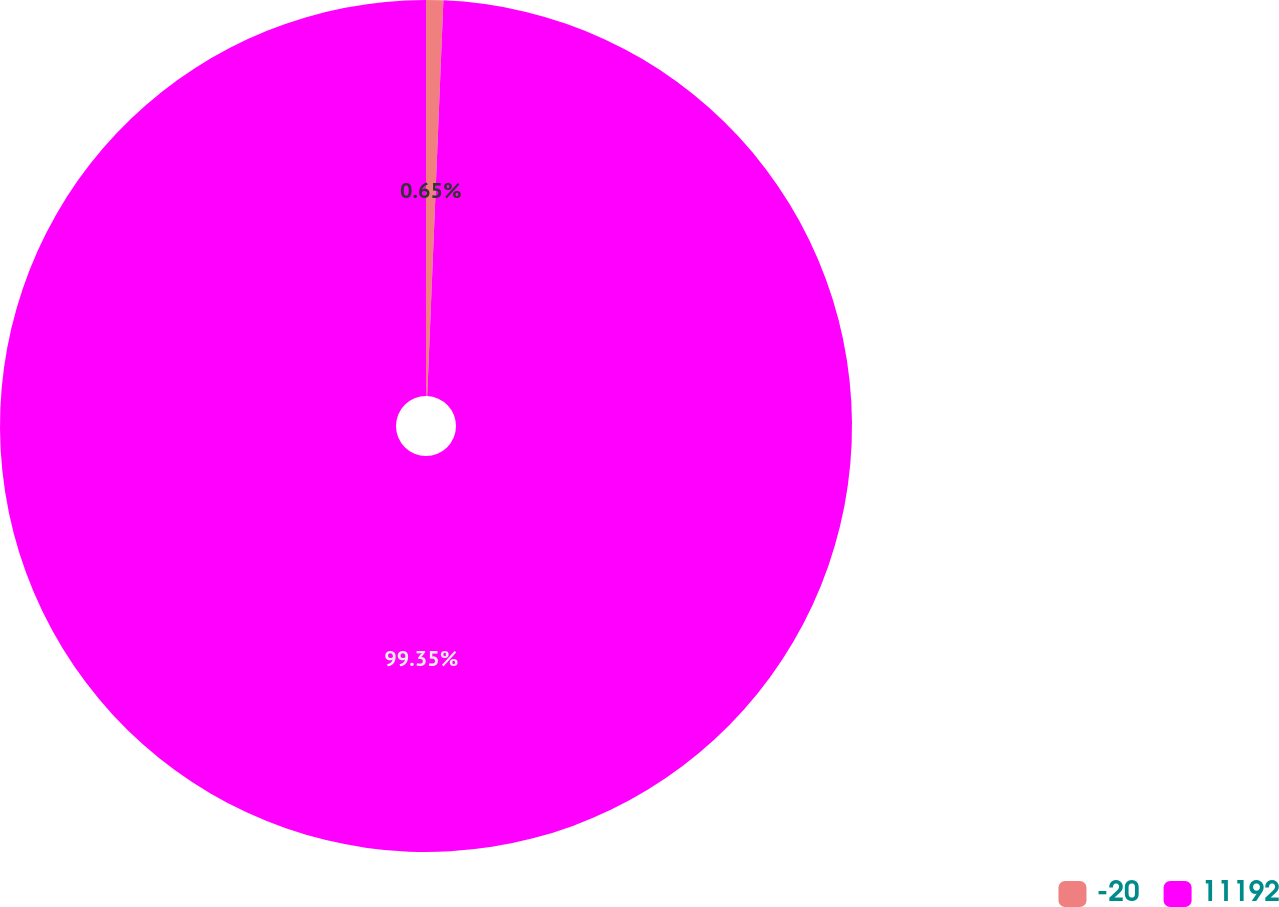<chart> <loc_0><loc_0><loc_500><loc_500><pie_chart><fcel>-20<fcel>11192<nl><fcel>0.65%<fcel>99.35%<nl></chart> 